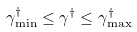Convert formula to latex. <formula><loc_0><loc_0><loc_500><loc_500>\gamma ^ { \dag } _ { \min } \leq \gamma ^ { \dag } \leq \gamma ^ { \dag } _ { \max }</formula> 